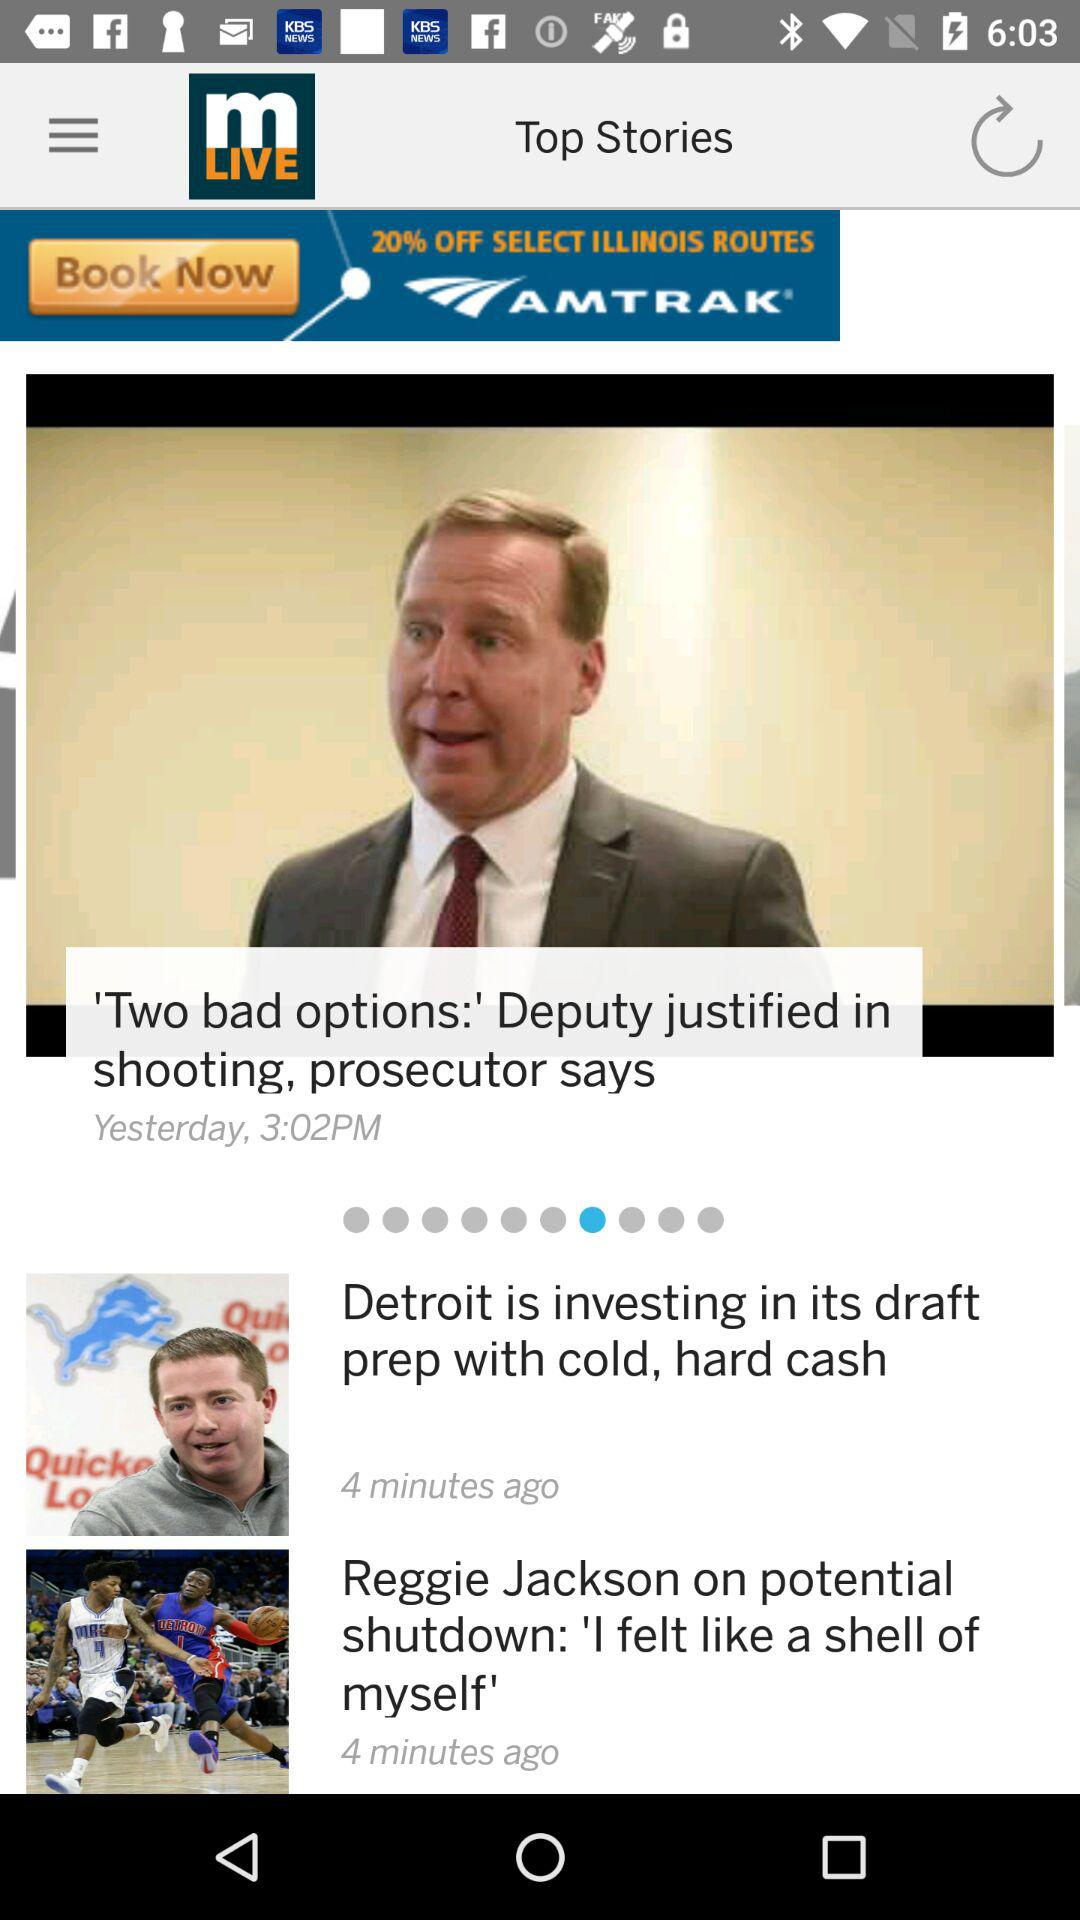When was the "I felt like a shell of myself" story posted? The "I felt like a shell of myself" story was posted 4 minutes ago. 